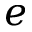Convert formula to latex. <formula><loc_0><loc_0><loc_500><loc_500>e</formula> 